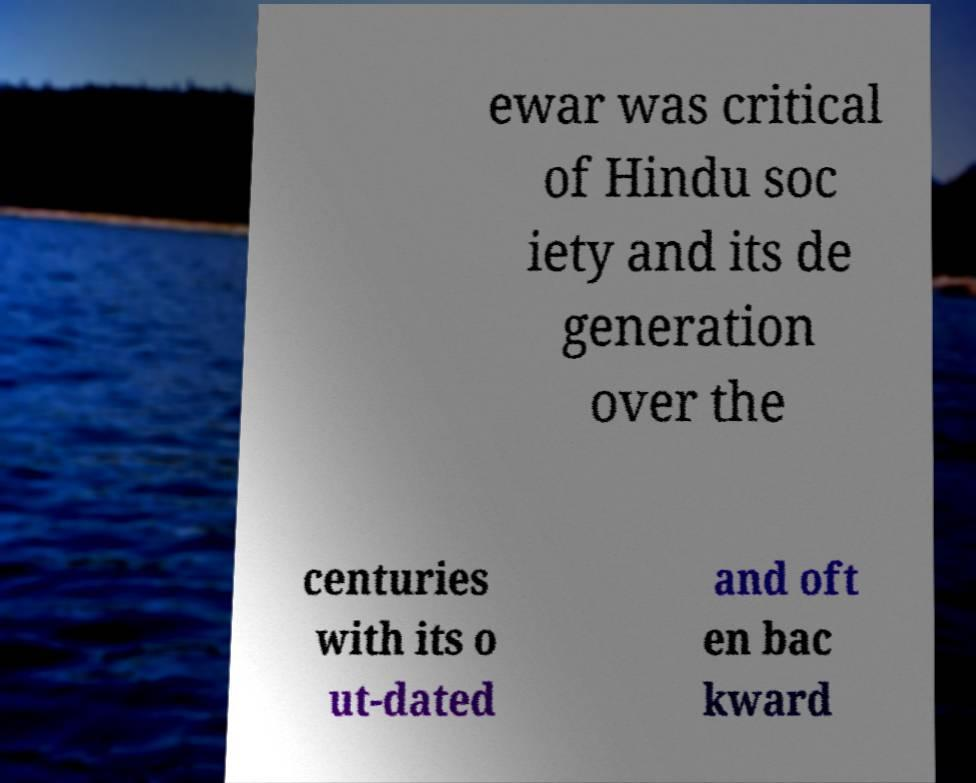There's text embedded in this image that I need extracted. Can you transcribe it verbatim? ewar was critical of Hindu soc iety and its de generation over the centuries with its o ut-dated and oft en bac kward 